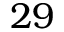<formula> <loc_0><loc_0><loc_500><loc_500>2 9</formula> 